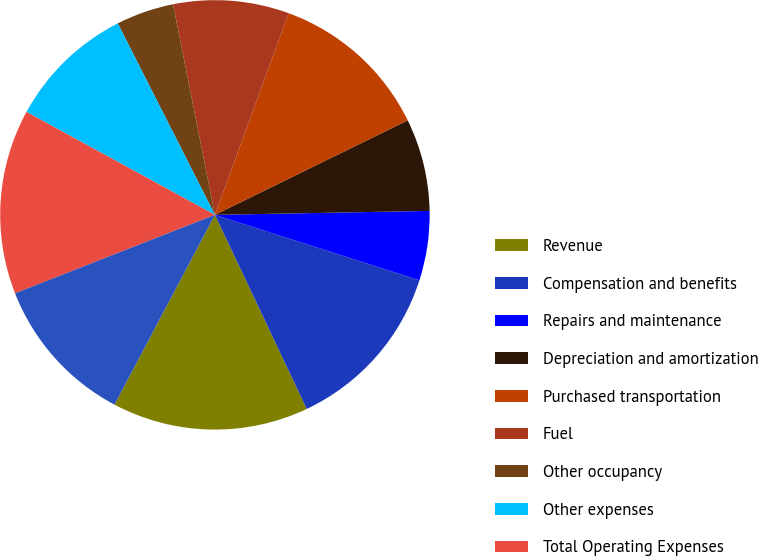<chart> <loc_0><loc_0><loc_500><loc_500><pie_chart><fcel>Revenue<fcel>Compensation and benefits<fcel>Repairs and maintenance<fcel>Depreciation and amortization<fcel>Purchased transportation<fcel>Fuel<fcel>Other occupancy<fcel>Other expenses<fcel>Total Operating Expenses<fcel>Operating Profit<nl><fcel>14.78%<fcel>13.04%<fcel>5.22%<fcel>6.96%<fcel>12.17%<fcel>8.7%<fcel>4.35%<fcel>9.57%<fcel>13.91%<fcel>11.3%<nl></chart> 